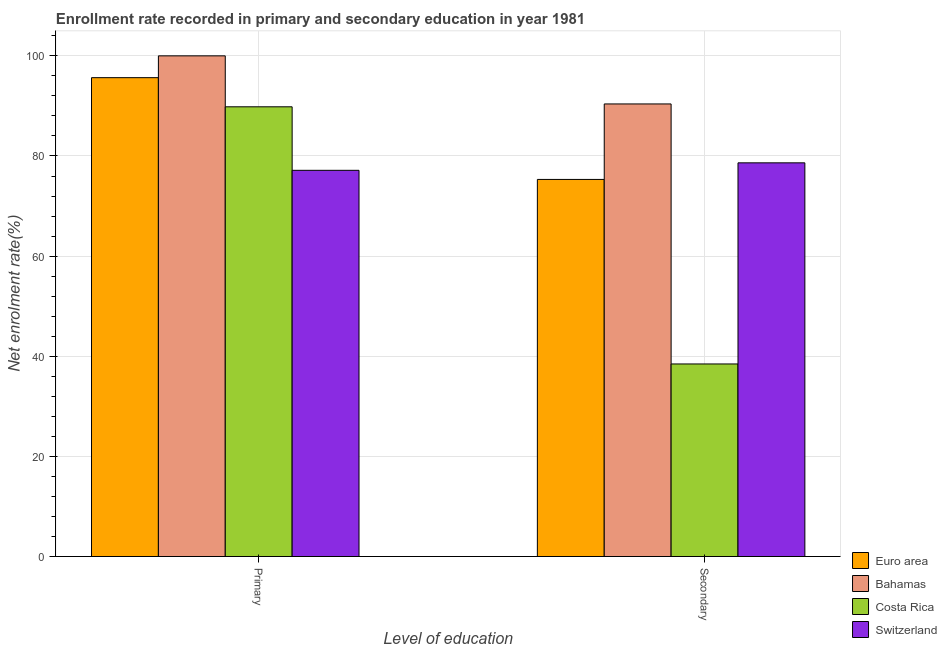How many different coloured bars are there?
Give a very brief answer. 4. How many groups of bars are there?
Make the answer very short. 2. Are the number of bars per tick equal to the number of legend labels?
Provide a succinct answer. Yes. How many bars are there on the 2nd tick from the right?
Provide a succinct answer. 4. What is the label of the 1st group of bars from the left?
Keep it short and to the point. Primary. What is the enrollment rate in secondary education in Costa Rica?
Provide a short and direct response. 38.46. Across all countries, what is the maximum enrollment rate in primary education?
Your answer should be very brief. 100. Across all countries, what is the minimum enrollment rate in secondary education?
Offer a terse response. 38.46. In which country was the enrollment rate in primary education maximum?
Your answer should be compact. Bahamas. In which country was the enrollment rate in primary education minimum?
Make the answer very short. Switzerland. What is the total enrollment rate in secondary education in the graph?
Your response must be concise. 282.81. What is the difference between the enrollment rate in secondary education in Euro area and that in Bahamas?
Ensure brevity in your answer.  -15.08. What is the difference between the enrollment rate in secondary education in Costa Rica and the enrollment rate in primary education in Euro area?
Provide a short and direct response. -57.18. What is the average enrollment rate in secondary education per country?
Your answer should be very brief. 70.7. What is the difference between the enrollment rate in primary education and enrollment rate in secondary education in Switzerland?
Offer a terse response. -1.49. What is the ratio of the enrollment rate in secondary education in Bahamas to that in Switzerland?
Provide a succinct answer. 1.15. Is the enrollment rate in secondary education in Bahamas less than that in Switzerland?
Provide a succinct answer. No. In how many countries, is the enrollment rate in primary education greater than the average enrollment rate in primary education taken over all countries?
Provide a short and direct response. 2. What does the 4th bar from the left in Secondary represents?
Provide a short and direct response. Switzerland. How many bars are there?
Offer a terse response. 8. How many countries are there in the graph?
Ensure brevity in your answer.  4. What is the difference between two consecutive major ticks on the Y-axis?
Make the answer very short. 20. Does the graph contain grids?
Provide a succinct answer. Yes. Where does the legend appear in the graph?
Your response must be concise. Bottom right. How many legend labels are there?
Your response must be concise. 4. What is the title of the graph?
Ensure brevity in your answer.  Enrollment rate recorded in primary and secondary education in year 1981. Does "North America" appear as one of the legend labels in the graph?
Keep it short and to the point. No. What is the label or title of the X-axis?
Keep it short and to the point. Level of education. What is the label or title of the Y-axis?
Your response must be concise. Net enrolment rate(%). What is the Net enrolment rate(%) of Euro area in Primary?
Give a very brief answer. 95.64. What is the Net enrolment rate(%) of Bahamas in Primary?
Provide a succinct answer. 100. What is the Net enrolment rate(%) of Costa Rica in Primary?
Make the answer very short. 89.82. What is the Net enrolment rate(%) of Switzerland in Primary?
Offer a very short reply. 77.14. What is the Net enrolment rate(%) of Euro area in Secondary?
Offer a very short reply. 75.32. What is the Net enrolment rate(%) in Bahamas in Secondary?
Provide a succinct answer. 90.4. What is the Net enrolment rate(%) of Costa Rica in Secondary?
Make the answer very short. 38.46. What is the Net enrolment rate(%) in Switzerland in Secondary?
Your answer should be very brief. 78.63. Across all Level of education, what is the maximum Net enrolment rate(%) in Euro area?
Provide a short and direct response. 95.64. Across all Level of education, what is the maximum Net enrolment rate(%) of Bahamas?
Give a very brief answer. 100. Across all Level of education, what is the maximum Net enrolment rate(%) of Costa Rica?
Keep it short and to the point. 89.82. Across all Level of education, what is the maximum Net enrolment rate(%) in Switzerland?
Offer a very short reply. 78.63. Across all Level of education, what is the minimum Net enrolment rate(%) of Euro area?
Provide a succinct answer. 75.32. Across all Level of education, what is the minimum Net enrolment rate(%) in Bahamas?
Ensure brevity in your answer.  90.4. Across all Level of education, what is the minimum Net enrolment rate(%) in Costa Rica?
Make the answer very short. 38.46. Across all Level of education, what is the minimum Net enrolment rate(%) of Switzerland?
Keep it short and to the point. 77.14. What is the total Net enrolment rate(%) in Euro area in the graph?
Keep it short and to the point. 170.96. What is the total Net enrolment rate(%) of Bahamas in the graph?
Offer a very short reply. 190.4. What is the total Net enrolment rate(%) in Costa Rica in the graph?
Give a very brief answer. 128.28. What is the total Net enrolment rate(%) of Switzerland in the graph?
Your answer should be compact. 155.77. What is the difference between the Net enrolment rate(%) of Euro area in Primary and that in Secondary?
Your answer should be compact. 20.32. What is the difference between the Net enrolment rate(%) in Bahamas in Primary and that in Secondary?
Make the answer very short. 9.6. What is the difference between the Net enrolment rate(%) in Costa Rica in Primary and that in Secondary?
Provide a succinct answer. 51.36. What is the difference between the Net enrolment rate(%) of Switzerland in Primary and that in Secondary?
Ensure brevity in your answer.  -1.49. What is the difference between the Net enrolment rate(%) of Euro area in Primary and the Net enrolment rate(%) of Bahamas in Secondary?
Give a very brief answer. 5.25. What is the difference between the Net enrolment rate(%) in Euro area in Primary and the Net enrolment rate(%) in Costa Rica in Secondary?
Offer a very short reply. 57.18. What is the difference between the Net enrolment rate(%) of Euro area in Primary and the Net enrolment rate(%) of Switzerland in Secondary?
Your answer should be very brief. 17.01. What is the difference between the Net enrolment rate(%) of Bahamas in Primary and the Net enrolment rate(%) of Costa Rica in Secondary?
Give a very brief answer. 61.54. What is the difference between the Net enrolment rate(%) in Bahamas in Primary and the Net enrolment rate(%) in Switzerland in Secondary?
Provide a succinct answer. 21.37. What is the difference between the Net enrolment rate(%) in Costa Rica in Primary and the Net enrolment rate(%) in Switzerland in Secondary?
Give a very brief answer. 11.19. What is the average Net enrolment rate(%) in Euro area per Level of education?
Keep it short and to the point. 85.48. What is the average Net enrolment rate(%) of Bahamas per Level of education?
Your response must be concise. 95.2. What is the average Net enrolment rate(%) of Costa Rica per Level of education?
Ensure brevity in your answer.  64.14. What is the average Net enrolment rate(%) of Switzerland per Level of education?
Offer a very short reply. 77.89. What is the difference between the Net enrolment rate(%) in Euro area and Net enrolment rate(%) in Bahamas in Primary?
Keep it short and to the point. -4.36. What is the difference between the Net enrolment rate(%) in Euro area and Net enrolment rate(%) in Costa Rica in Primary?
Keep it short and to the point. 5.82. What is the difference between the Net enrolment rate(%) in Euro area and Net enrolment rate(%) in Switzerland in Primary?
Give a very brief answer. 18.5. What is the difference between the Net enrolment rate(%) of Bahamas and Net enrolment rate(%) of Costa Rica in Primary?
Your answer should be very brief. 10.18. What is the difference between the Net enrolment rate(%) of Bahamas and Net enrolment rate(%) of Switzerland in Primary?
Keep it short and to the point. 22.86. What is the difference between the Net enrolment rate(%) of Costa Rica and Net enrolment rate(%) of Switzerland in Primary?
Offer a very short reply. 12.68. What is the difference between the Net enrolment rate(%) in Euro area and Net enrolment rate(%) in Bahamas in Secondary?
Provide a short and direct response. -15.08. What is the difference between the Net enrolment rate(%) of Euro area and Net enrolment rate(%) of Costa Rica in Secondary?
Offer a terse response. 36.86. What is the difference between the Net enrolment rate(%) in Euro area and Net enrolment rate(%) in Switzerland in Secondary?
Your response must be concise. -3.31. What is the difference between the Net enrolment rate(%) of Bahamas and Net enrolment rate(%) of Costa Rica in Secondary?
Keep it short and to the point. 51.94. What is the difference between the Net enrolment rate(%) in Bahamas and Net enrolment rate(%) in Switzerland in Secondary?
Offer a very short reply. 11.76. What is the difference between the Net enrolment rate(%) in Costa Rica and Net enrolment rate(%) in Switzerland in Secondary?
Make the answer very short. -40.17. What is the ratio of the Net enrolment rate(%) in Euro area in Primary to that in Secondary?
Ensure brevity in your answer.  1.27. What is the ratio of the Net enrolment rate(%) in Bahamas in Primary to that in Secondary?
Offer a terse response. 1.11. What is the ratio of the Net enrolment rate(%) in Costa Rica in Primary to that in Secondary?
Keep it short and to the point. 2.34. What is the ratio of the Net enrolment rate(%) of Switzerland in Primary to that in Secondary?
Your answer should be very brief. 0.98. What is the difference between the highest and the second highest Net enrolment rate(%) of Euro area?
Offer a very short reply. 20.32. What is the difference between the highest and the second highest Net enrolment rate(%) of Bahamas?
Your answer should be compact. 9.6. What is the difference between the highest and the second highest Net enrolment rate(%) of Costa Rica?
Your answer should be compact. 51.36. What is the difference between the highest and the second highest Net enrolment rate(%) in Switzerland?
Make the answer very short. 1.49. What is the difference between the highest and the lowest Net enrolment rate(%) in Euro area?
Ensure brevity in your answer.  20.32. What is the difference between the highest and the lowest Net enrolment rate(%) in Bahamas?
Offer a terse response. 9.6. What is the difference between the highest and the lowest Net enrolment rate(%) in Costa Rica?
Your answer should be very brief. 51.36. What is the difference between the highest and the lowest Net enrolment rate(%) of Switzerland?
Keep it short and to the point. 1.49. 